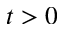Convert formula to latex. <formula><loc_0><loc_0><loc_500><loc_500>t > 0</formula> 